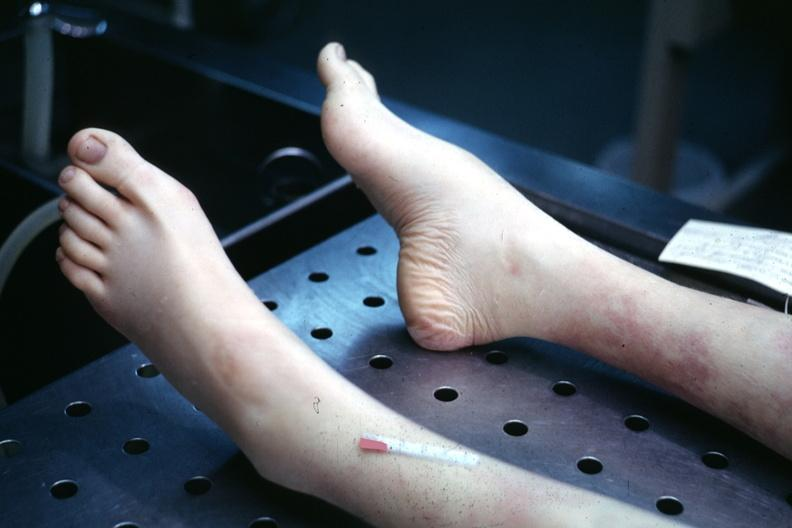does this image show 22wf juvenile rheumatoid arthritis mild deformity with high arch?
Answer the question using a single word or phrase. Yes 